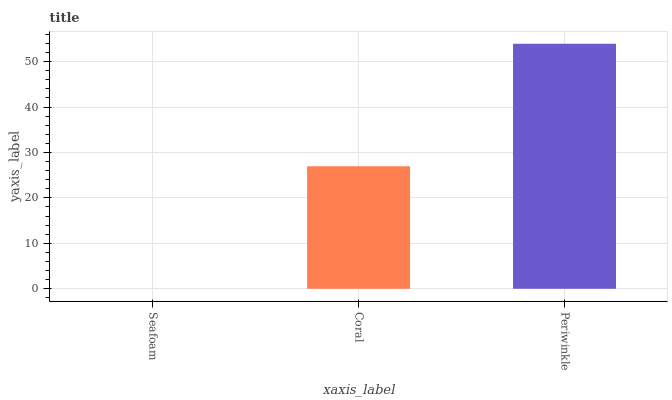Is Seafoam the minimum?
Answer yes or no. Yes. Is Periwinkle the maximum?
Answer yes or no. Yes. Is Coral the minimum?
Answer yes or no. No. Is Coral the maximum?
Answer yes or no. No. Is Coral greater than Seafoam?
Answer yes or no. Yes. Is Seafoam less than Coral?
Answer yes or no. Yes. Is Seafoam greater than Coral?
Answer yes or no. No. Is Coral less than Seafoam?
Answer yes or no. No. Is Coral the high median?
Answer yes or no. Yes. Is Coral the low median?
Answer yes or no. Yes. Is Periwinkle the high median?
Answer yes or no. No. Is Seafoam the low median?
Answer yes or no. No. 